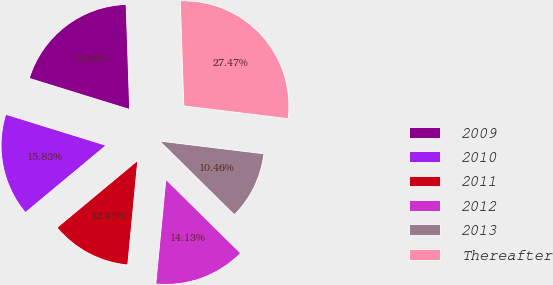<chart> <loc_0><loc_0><loc_500><loc_500><pie_chart><fcel>2009<fcel>2010<fcel>2011<fcel>2012<fcel>2013<fcel>Thereafter<nl><fcel>19.68%<fcel>15.83%<fcel>12.43%<fcel>14.13%<fcel>10.46%<fcel>27.47%<nl></chart> 